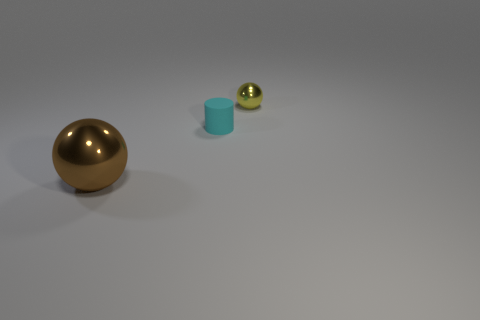What is the atmosphere or mood conveyed by this image? The image gives off a minimalist and clean atmosphere, due to the plain background and the simple, isolated presentation of the objects. The lighting and shadowing suggest a calm and controlled environment, free from any chaos or clutter. 